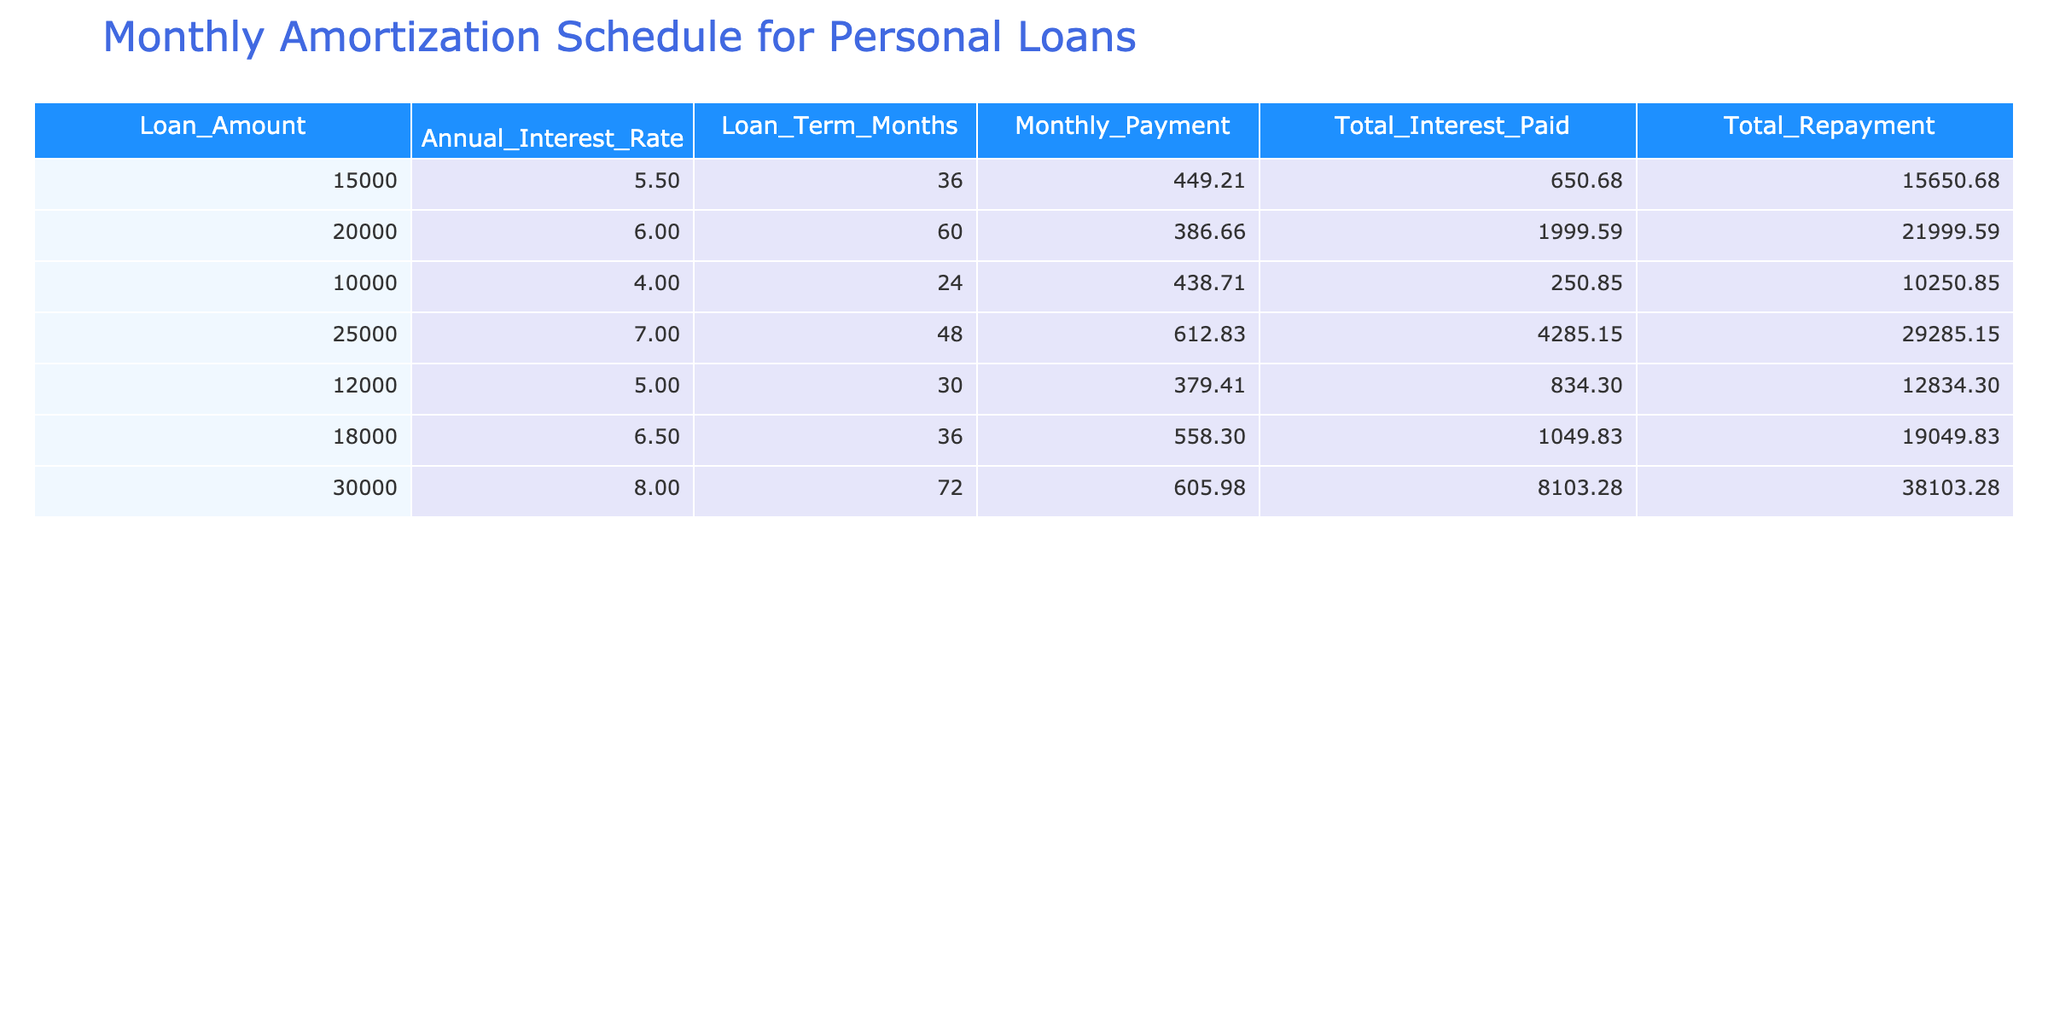What is the loan amount for the loan with the highest total repayment? The loan with the highest total repayment is the one for 30000, which has a total repayment of 38103.28.
Answer: 30000 What is the monthly payment for a loan amount of 18000? The monthly payment for a loan amount of 18000 is listed in the table as 558.30.
Answer: 558.30 Is the total interest paid for a loan of 25000 greater than that for a loan of 15000? The total interest paid for the 25000 loan is 4285.15, and for the 15000 loan, it is 650.68. Since 4285.15 is greater than 650.68, the statement is true.
Answer: Yes What is the average annual interest rate of all loans listed? To find the average, we sum the annual interest rates: (5.5 + 6.0 + 4.0 + 7.0 + 5.0 + 6.5 + 8.0) = 42.0. There are 7 loans, so the average annual interest rate is 42.0/7 = 6.0.
Answer: 6.0 Which loan term has the highest monthly payment? The loan with the highest monthly payment is for the 25000 loan amount with a monthly payment of 612.83.
Answer: 48 months What is the total repayment of the loan with the lowest monthly payment? The loan with the lowest monthly payment is for 20000, and its total repayment is 21999.59.
Answer: 21999.59 Is there any loan with a total repayment that exceeds 30000? The loan with the total repayment exceeding 30000 is the loan for 30000, which has 38103.28 as total repayment. Thus, the answer is yes.
Answer: Yes What is the difference in total interest paid between the 10000 loan and the 15000 loan? The total interest paid for the 10000 loan is 250.85 and for the 15000 loan is 650.68. The difference is calculated as 650.68 - 250.85 = 399.83.
Answer: 399.83 